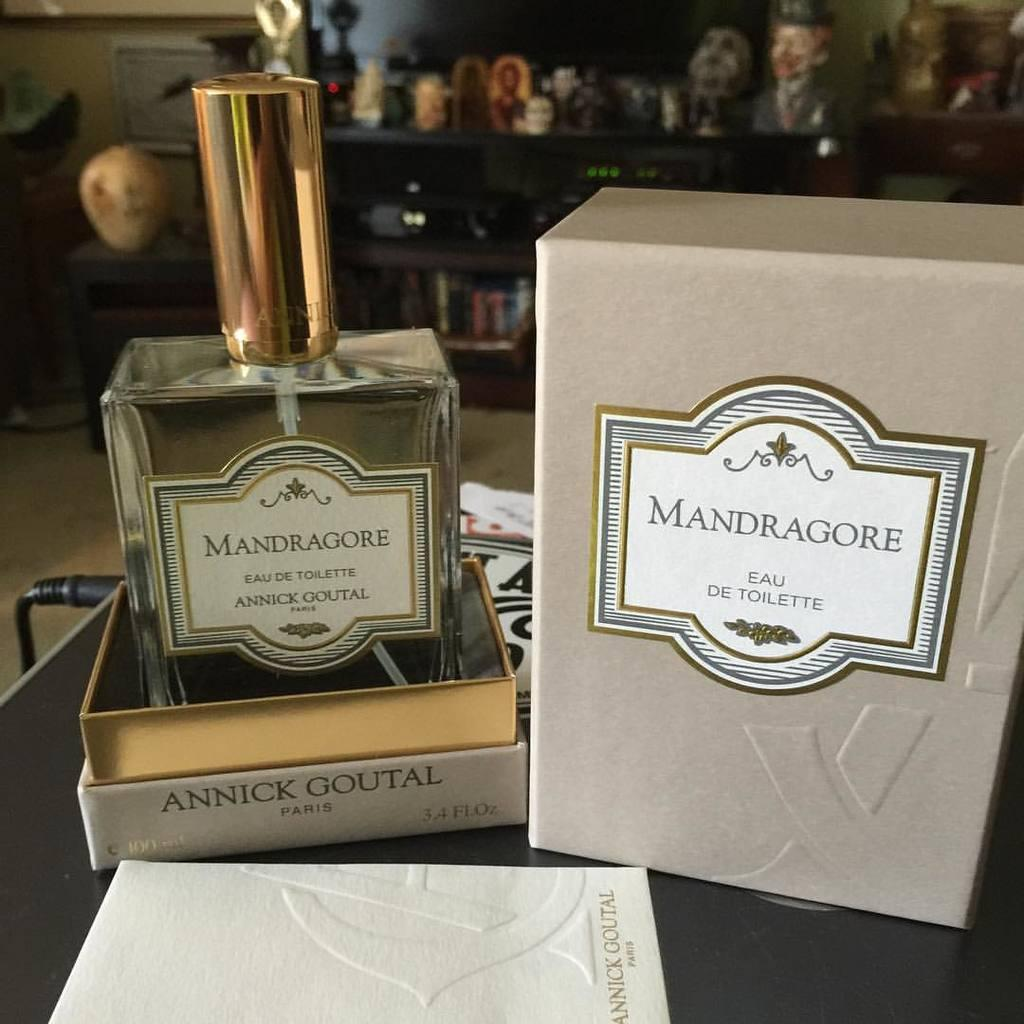<image>
Create a compact narrative representing the image presented. Box of Mandragore eau de toilette and Mandragore paris 